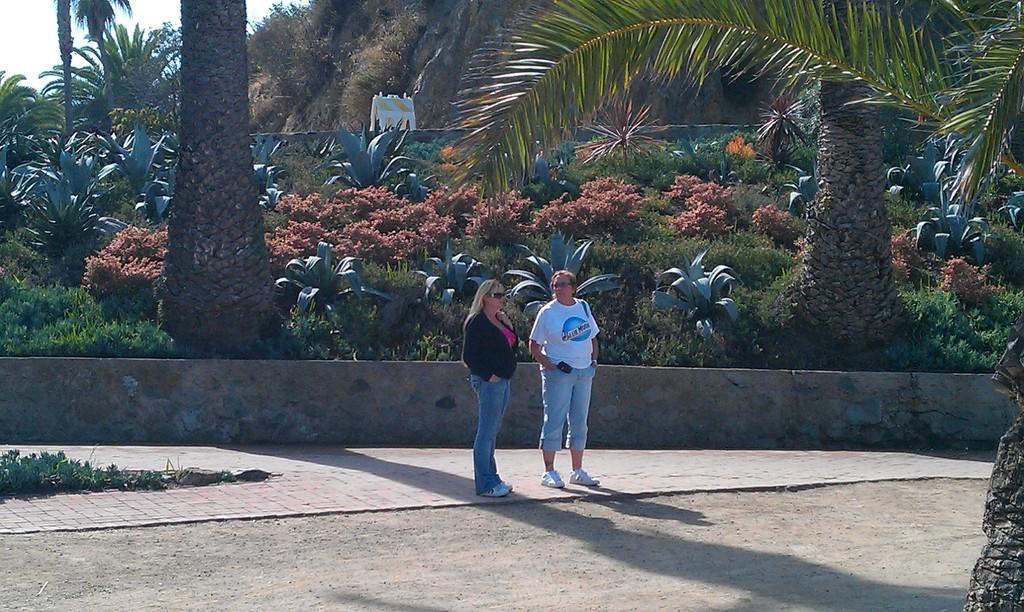How many women are present in the image? There are two women in the image. What are the women doing in the image? The women are standing on a footpath. What can be seen in the background of the image? There are trees, plants, and the sky visible in the background of the image. What time of day is indicated by the hour on the clock tower in the image? There is no clock tower present in the image, so it is not possible to determine the time of day. 